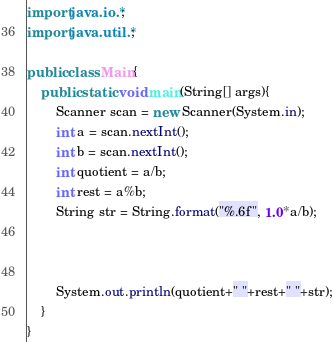Convert code to text. <code><loc_0><loc_0><loc_500><loc_500><_Java_>import java.io.*;
import java.util.*;

public class Main{
	public static void main(String[] args){
		Scanner scan = new Scanner(System.in);
		int a = scan.nextInt();
		int b = scan.nextInt();
		int quotient = a/b;
		int rest = a%b;
		String str = String.format("%.6f", 1.0*a/b);
		


		System.out.println(quotient+" "+rest+" "+str);
	}
}</code> 